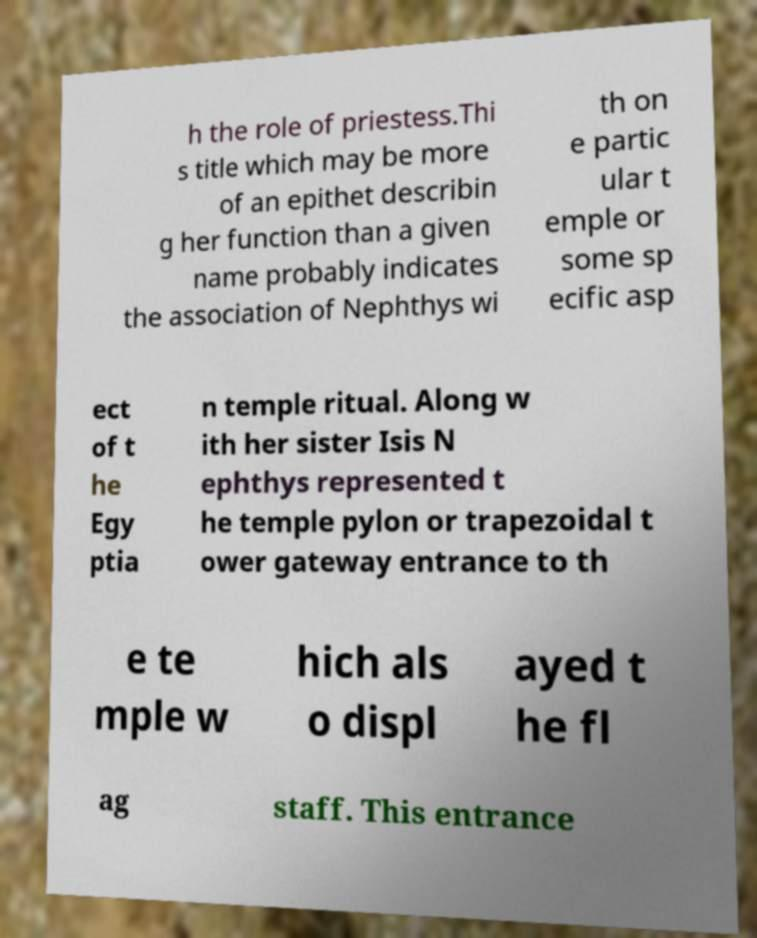Please read and relay the text visible in this image. What does it say? h the role of priestess.Thi s title which may be more of an epithet describin g her function than a given name probably indicates the association of Nephthys wi th on e partic ular t emple or some sp ecific asp ect of t he Egy ptia n temple ritual. Along w ith her sister Isis N ephthys represented t he temple pylon or trapezoidal t ower gateway entrance to th e te mple w hich als o displ ayed t he fl ag staff. This entrance 